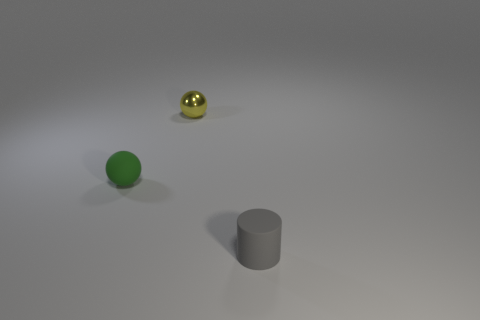Add 3 brown metallic cubes. How many objects exist? 6 Subtract all cylinders. How many objects are left? 2 Add 2 tiny red cubes. How many tiny red cubes exist? 2 Subtract 0 cyan balls. How many objects are left? 3 Subtract all shiny spheres. Subtract all big yellow cylinders. How many objects are left? 2 Add 3 tiny rubber balls. How many tiny rubber balls are left? 4 